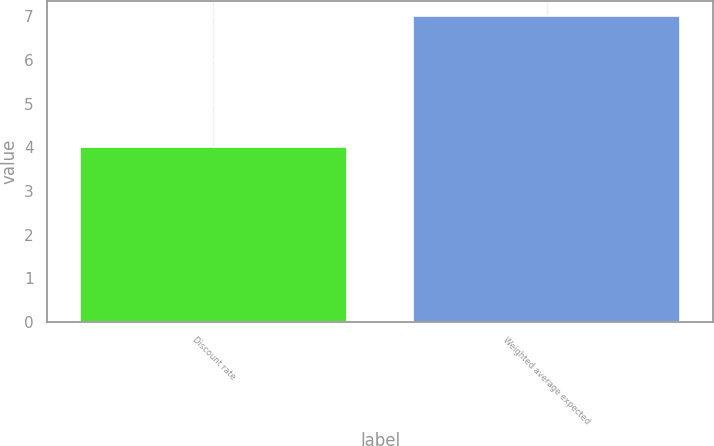Convert chart to OTSL. <chart><loc_0><loc_0><loc_500><loc_500><bar_chart><fcel>Discount rate<fcel>Weighted average expected<nl><fcel>4<fcel>7<nl></chart> 